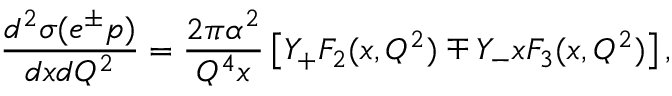<formula> <loc_0><loc_0><loc_500><loc_500>\frac { d ^ { 2 } \sigma ( e ^ { \pm } p ) } { d x d Q ^ { 2 } } = \frac { 2 \pi \alpha ^ { 2 } } { Q ^ { 4 } x } \left [ Y _ { + } F _ { 2 } ( x , Q ^ { 2 } ) \mp Y _ { - } x F _ { 3 } ( x , Q ^ { 2 } ) \right ] ,</formula> 